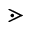Convert formula to latex. <formula><loc_0><loc_0><loc_500><loc_500>\gtrdot</formula> 